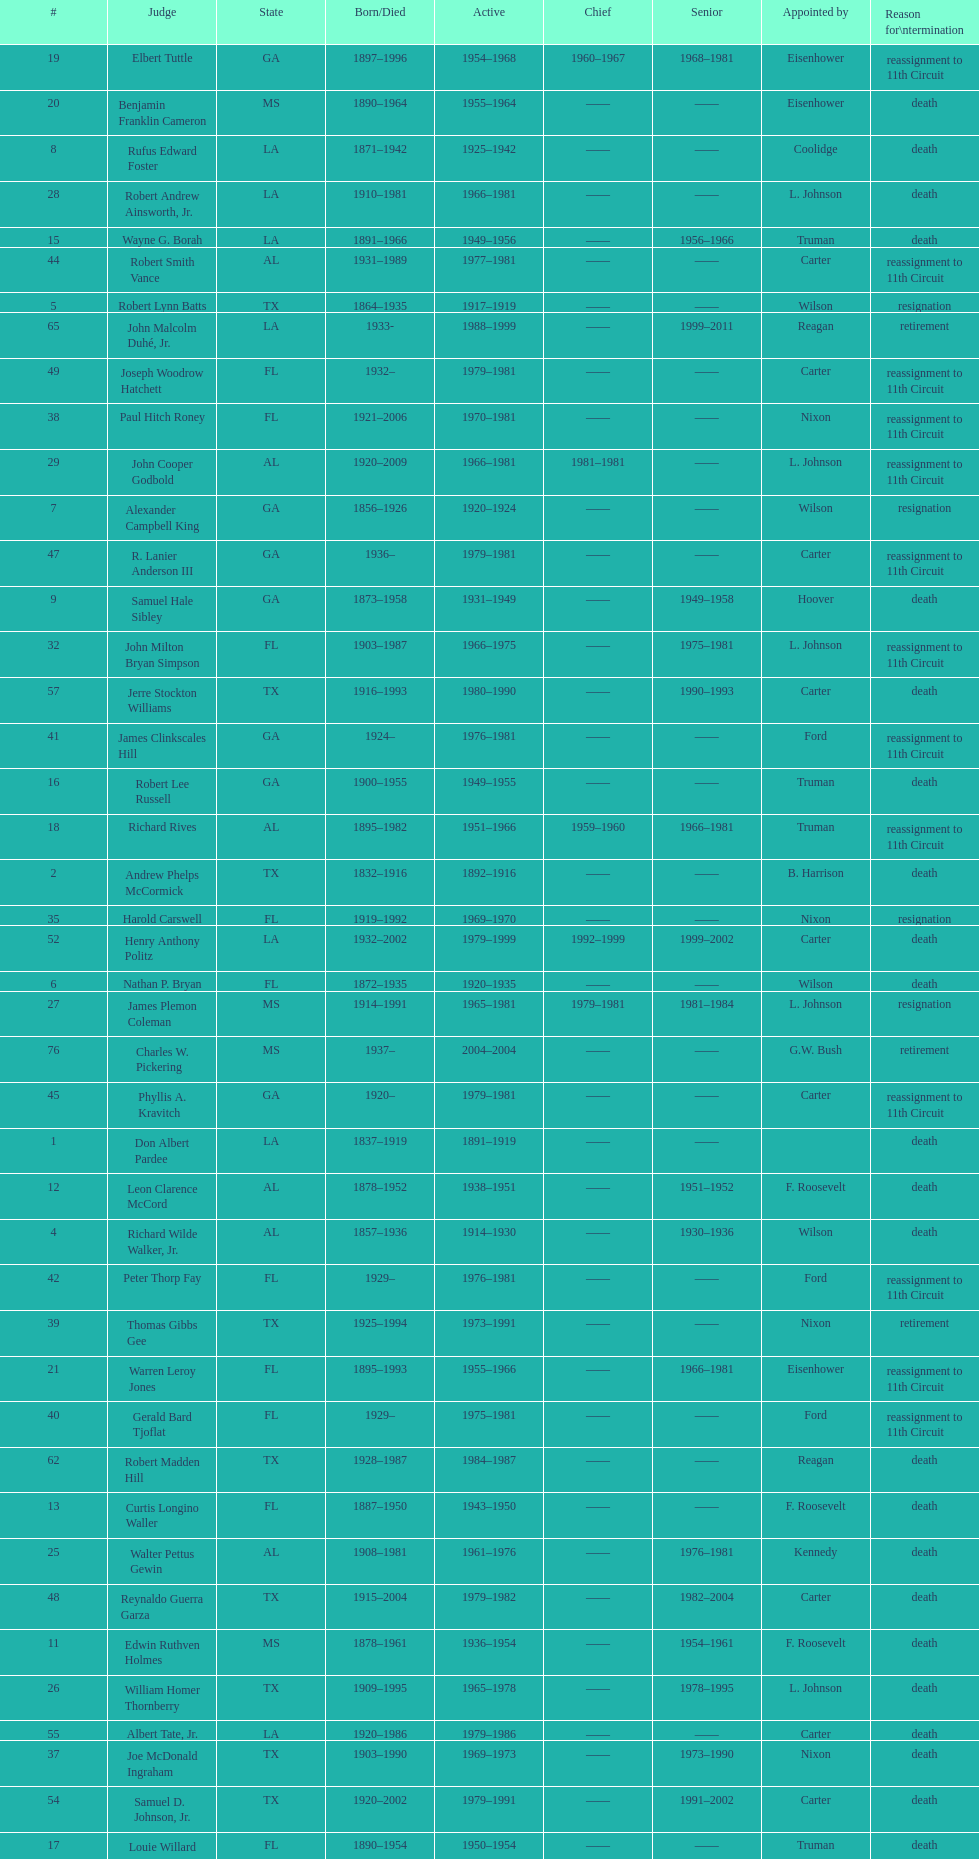Who was the only judge appointed by mckinley? David Davie Shelby. 